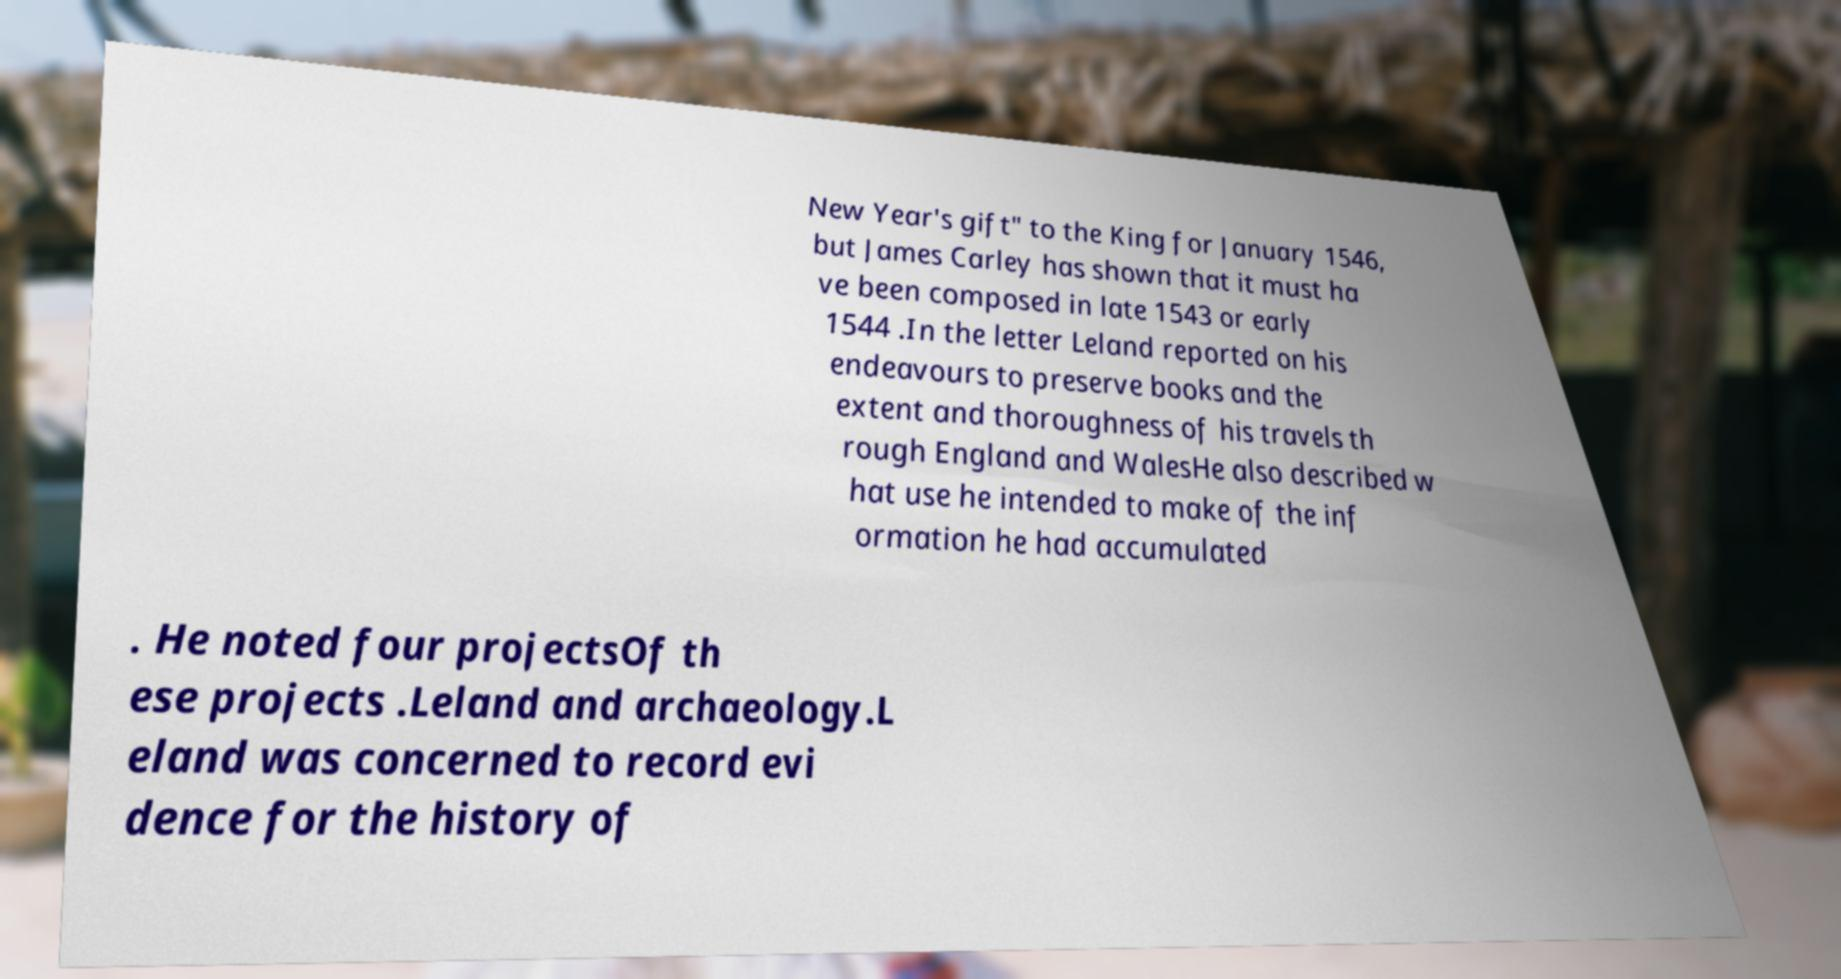There's text embedded in this image that I need extracted. Can you transcribe it verbatim? New Year's gift" to the King for January 1546, but James Carley has shown that it must ha ve been composed in late 1543 or early 1544 .In the letter Leland reported on his endeavours to preserve books and the extent and thoroughness of his travels th rough England and WalesHe also described w hat use he intended to make of the inf ormation he had accumulated . He noted four projectsOf th ese projects .Leland and archaeology.L eland was concerned to record evi dence for the history of 